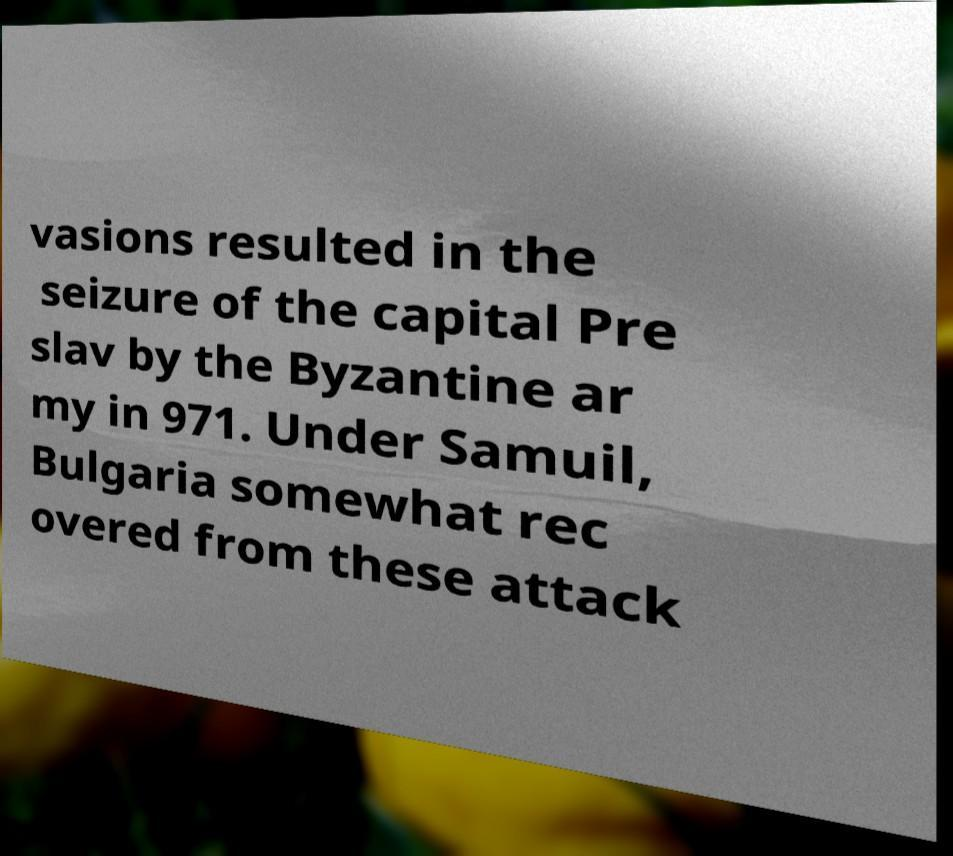Can you read and provide the text displayed in the image?This photo seems to have some interesting text. Can you extract and type it out for me? vasions resulted in the seizure of the capital Pre slav by the Byzantine ar my in 971. Under Samuil, Bulgaria somewhat rec overed from these attack 